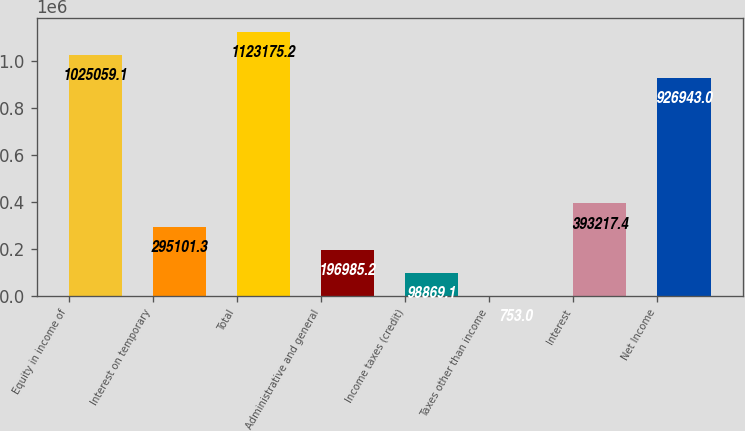Convert chart to OTSL. <chart><loc_0><loc_0><loc_500><loc_500><bar_chart><fcel>Equity in income of<fcel>Interest on temporary<fcel>Total<fcel>Administrative and general<fcel>Income taxes (credit)<fcel>Taxes other than income<fcel>Interest<fcel>Net Income<nl><fcel>1.02506e+06<fcel>295101<fcel>1.12318e+06<fcel>196985<fcel>98869.1<fcel>753<fcel>393217<fcel>926943<nl></chart> 